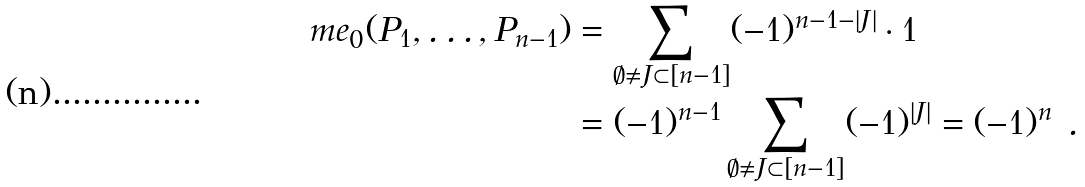<formula> <loc_0><loc_0><loc_500><loc_500>\ m e _ { 0 } ( P _ { 1 } , \dots , P _ { n - 1 } ) & = \sum _ { \emptyset \neq J \subset [ n - 1 ] } ( - 1 ) ^ { n - 1 - | J | } \cdot 1 \\ & = ( - 1 ) ^ { n - 1 } \sum _ { \emptyset \neq J \subset [ n - 1 ] } ( - 1 ) ^ { | J | } = ( - 1 ) ^ { n } \ .</formula> 